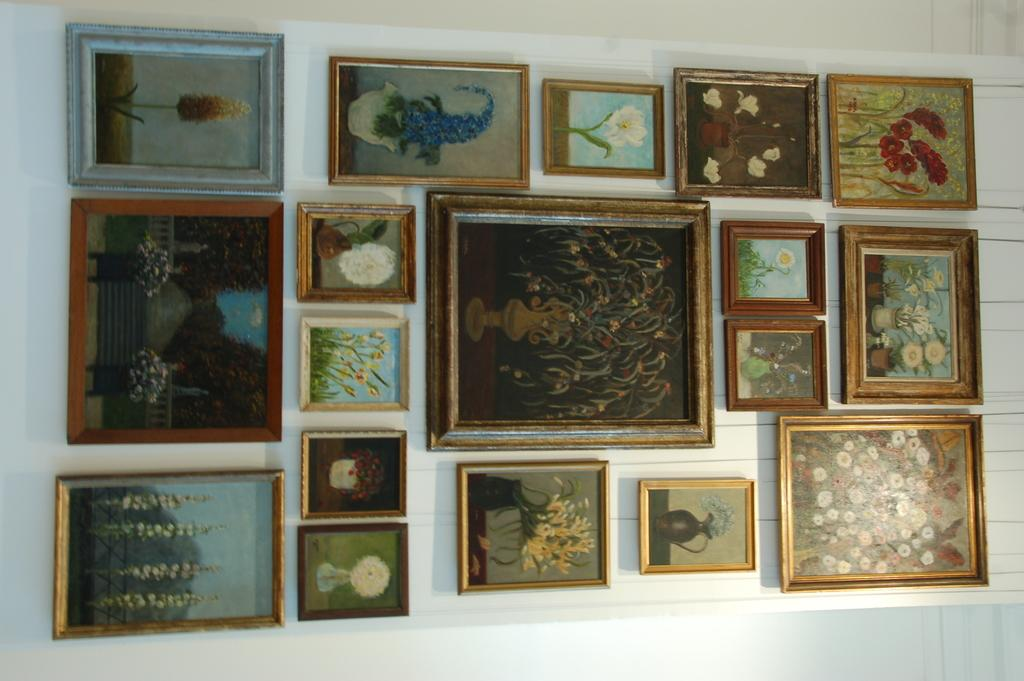What objects are hanging on the wall in the image? There are photo frames on the wall in the image. How many stems are visible in the photo frames in the image? There is no reference to stems in the image, as it features photo frames on the wall. 